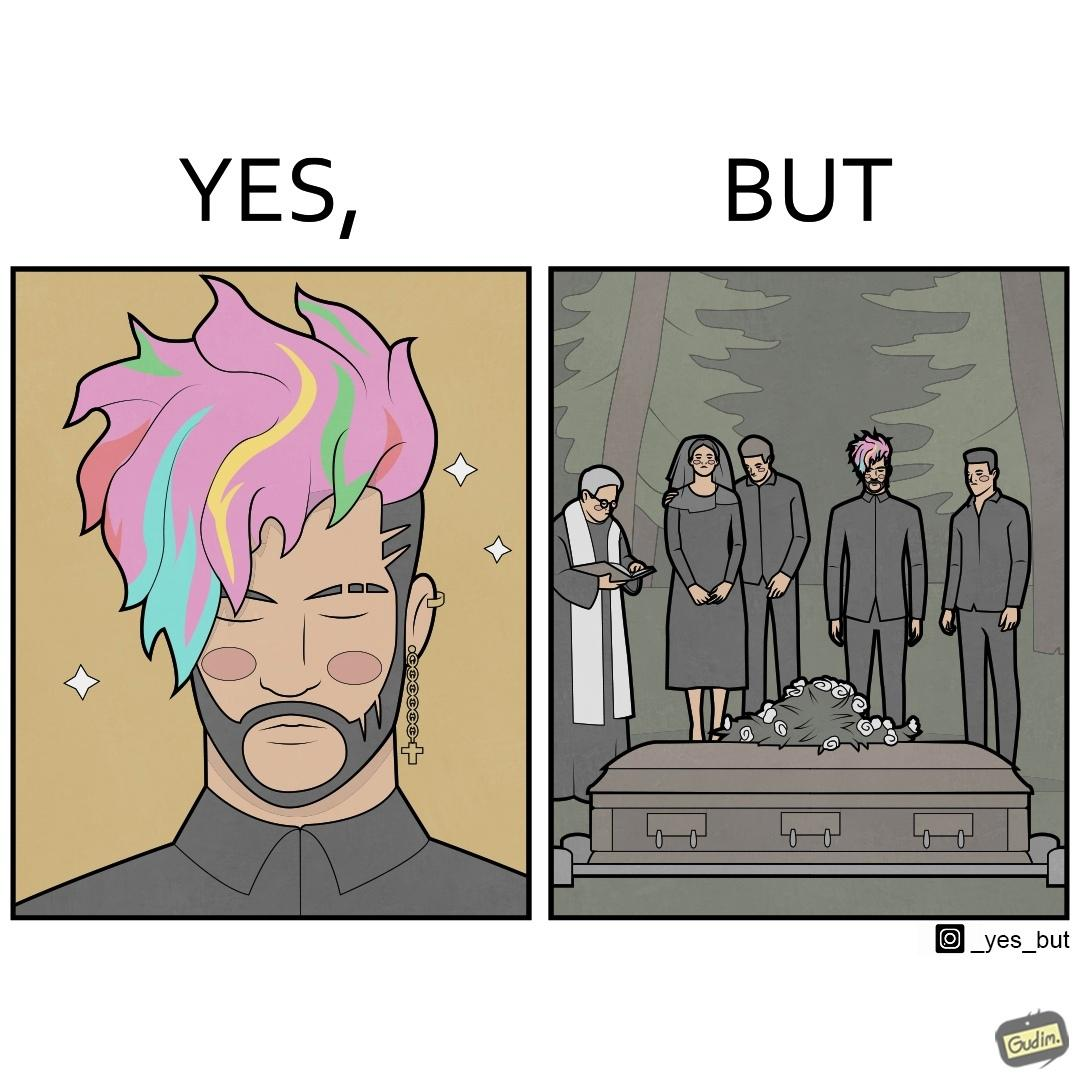What is shown in this image? The image is ironic, because in the second image it is shown that a group of people is attending someone's death ceremony but one of them is shown as wrongly dressed for that place in first image, his visual appearances doesn't shows his feeling of mourning 